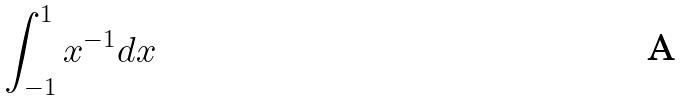Convert formula to latex. <formula><loc_0><loc_0><loc_500><loc_500>\int _ { - 1 } ^ { 1 } x ^ { - 1 } d x</formula> 